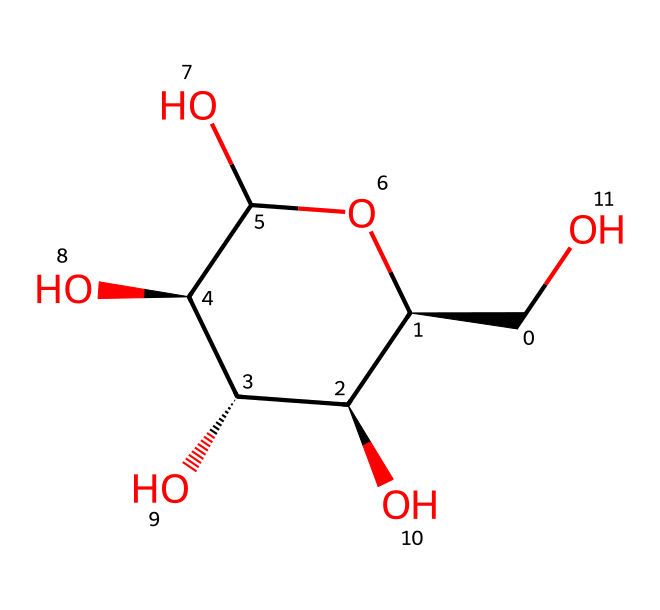What is the molecular formula of glucose? To determine the molecular formula, we count the atoms present in the structure. Glucose has six carbon (C) atoms, twelve hydrogen (H) atoms, and six oxygen (O) atoms, which gives us the formula C6H12O6.
Answer: C6H12O6 How many hydroxyl groups are present in this glucose structure? By examining the chemical structure, we can identify that there are five hydroxyl (–OH) groups attached to the carbon atoms of the glucose molecule.
Answer: five What type of isomerism is exhibited by glucose? Glucose exhibits stereoisomerism due to the presence of multiple chiral centers (carbon atoms attached to four different substituents), which allows for multiple stereoisomers.
Answer: stereoisomerism How many chiral centers are present in this glucose molecule? In the structural representation, there are four carbon atoms that each bear different substituents, meaning there are four chiral centers in glucose.
Answer: four Which type of carbohydrate is glucose classified as? Glucose is classified as a monosaccharide, which is the simplest form of carbohydrates consisting of a single sugar molecule.
Answer: monosaccharide What is the role of the hydroxyl groups in glucose? The hydroxyl groups in glucose are crucial for its solubility in water and for the formation of hydrogen bonds, which affect its reactivity and biological functions.
Answer: solubility and reactivity 